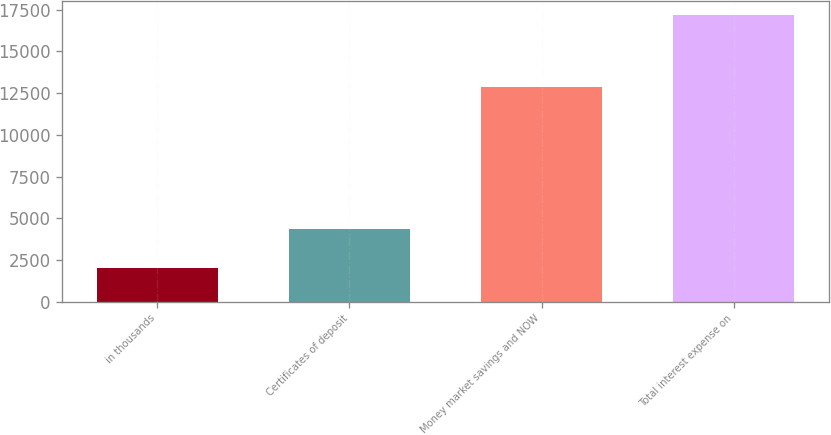Convert chart. <chart><loc_0><loc_0><loc_500><loc_500><bar_chart><fcel>in thousands<fcel>Certificates of deposit<fcel>Money market savings and NOW<fcel>Total interest expense on<nl><fcel>2017<fcel>4325<fcel>12859<fcel>17184<nl></chart> 